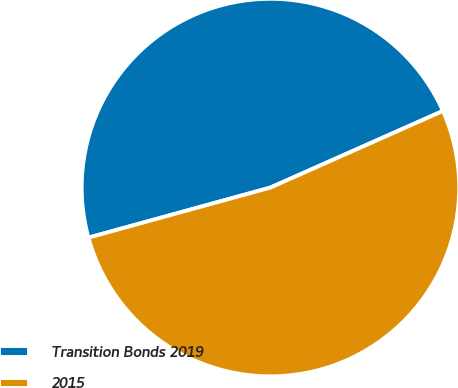Convert chart. <chart><loc_0><loc_0><loc_500><loc_500><pie_chart><fcel>Transition Bonds 2019<fcel>2015<nl><fcel>47.62%<fcel>52.38%<nl></chart> 